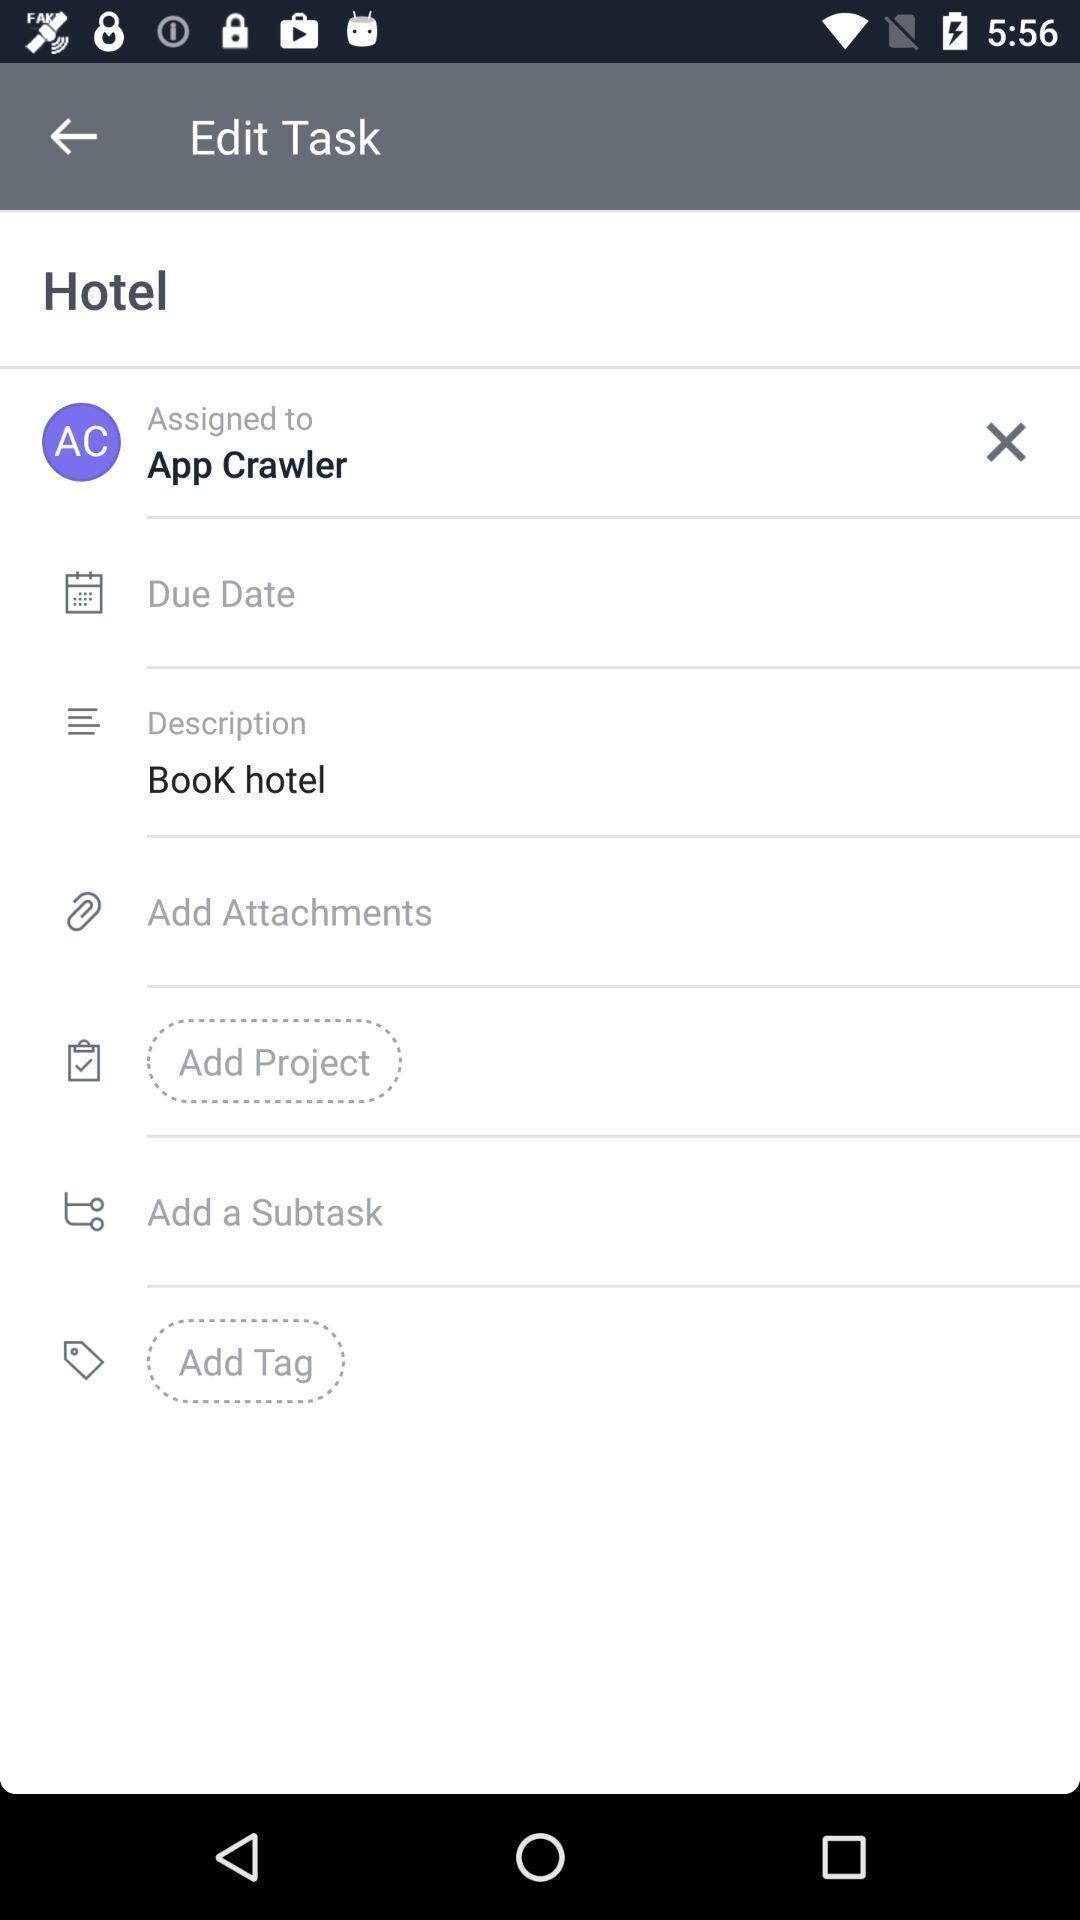Please provide a description for this image. Page showing the options task app. 